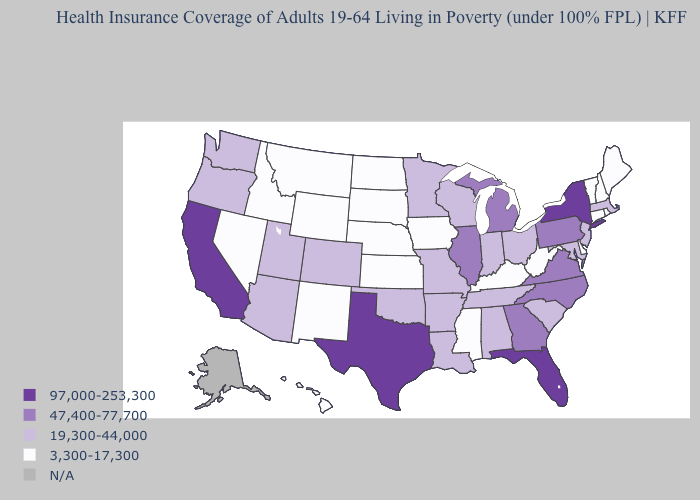Name the states that have a value in the range 97,000-253,300?
Give a very brief answer. California, Florida, New York, Texas. Does California have the highest value in the USA?
Write a very short answer. Yes. What is the value of New Jersey?
Concise answer only. 19,300-44,000. What is the value of Nebraska?
Concise answer only. 3,300-17,300. How many symbols are there in the legend?
Concise answer only. 5. Does North Dakota have the lowest value in the MidWest?
Keep it brief. Yes. Does the first symbol in the legend represent the smallest category?
Keep it brief. No. Does Massachusetts have the lowest value in the Northeast?
Be succinct. No. What is the value of Texas?
Write a very short answer. 97,000-253,300. Does New Hampshire have the highest value in the USA?
Keep it brief. No. What is the lowest value in states that border Wisconsin?
Quick response, please. 3,300-17,300. What is the lowest value in the USA?
Answer briefly. 3,300-17,300. Name the states that have a value in the range N/A?
Write a very short answer. Alaska. Name the states that have a value in the range 19,300-44,000?
Give a very brief answer. Alabama, Arizona, Arkansas, Colorado, Indiana, Louisiana, Maryland, Massachusetts, Minnesota, Missouri, New Jersey, Ohio, Oklahoma, Oregon, South Carolina, Tennessee, Utah, Washington, Wisconsin. Among the states that border Colorado , which have the highest value?
Be succinct. Arizona, Oklahoma, Utah. 